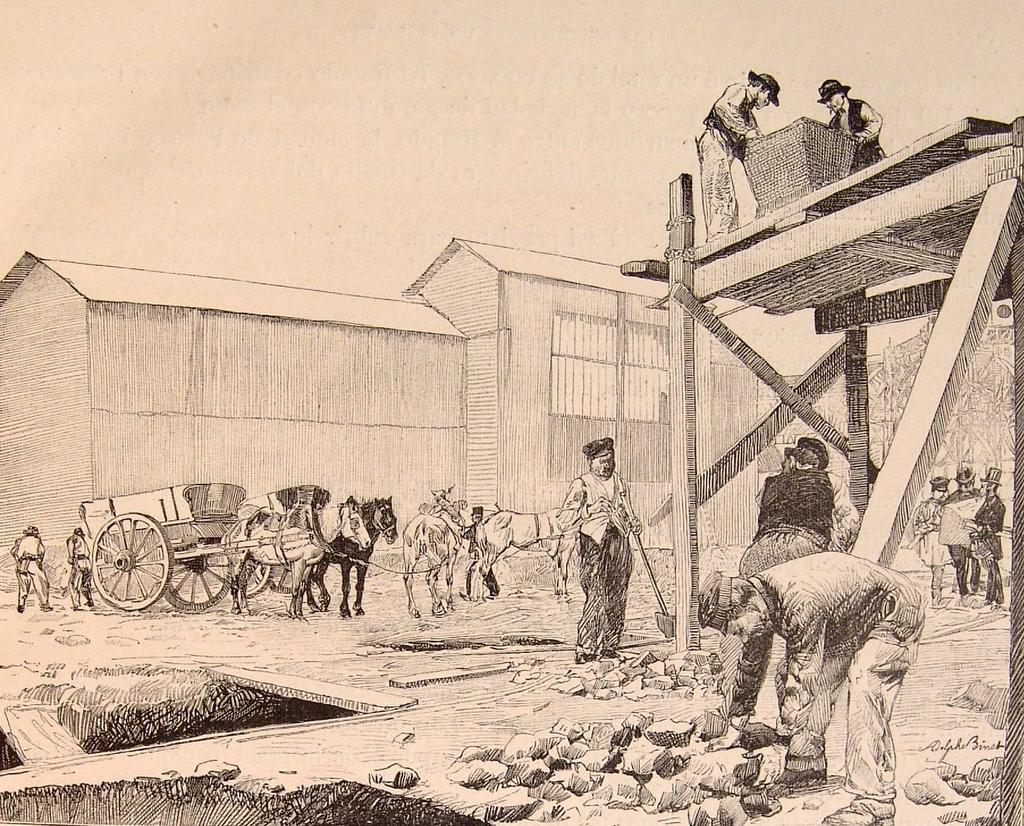What is depicted in the drawing in the image? There is a drawing of stones on the ground in the image. Who or what can be seen in the image besides the drawing? There are people, a horse cart, animals, a building, wooden planks, and other objects present in the image. What type of vehicle is in the image? There is a horse cart in the image. What kind of structure is visible in the image? There is a building in the image. How many apples are being juggled by the animals in the image? There are no apples or juggling depicted in the image; it features a drawing of stones on the ground, people, a horse cart, animals, a building, wooden planks, and other objects. 